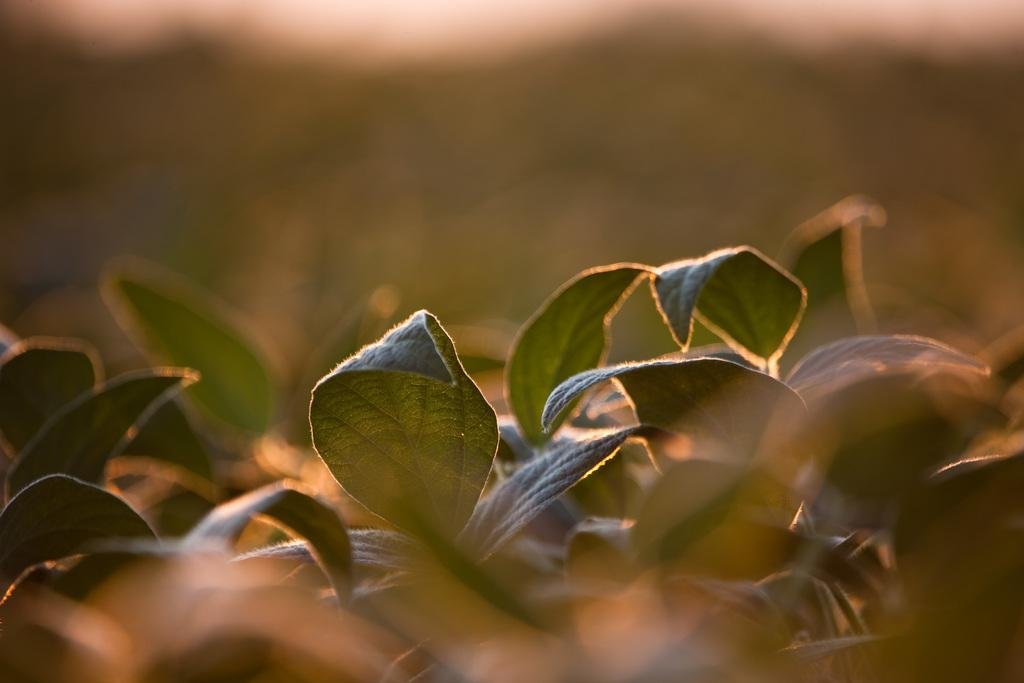What type of vegetation can be seen in the image? There are leaves in the image. Can you describe the background of the image? The background of the image is blurred. Are there any shoes visible in the image? There are no shoes present in the image. Is the ground covered in snow in the image? There is no snow visible in the image. Can you see a railway in the image? There is no railway present in the image. 